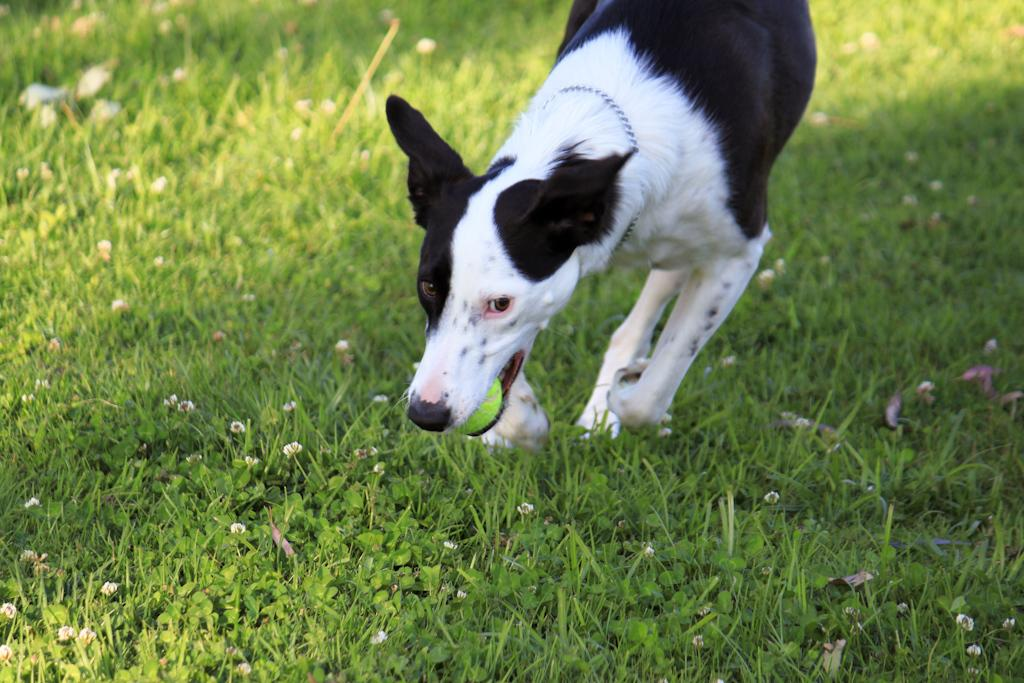What animal is present in the image? There is a dog in the image. What is the dog doing with its mouth? The dog is holding a ball in its mouth. What type of surface is visible at the bottom of the image? There is grass at the bottom of the image. What color crayon is the dog using to draw in the image? There is no crayon present in the image, and the dog is not drawing. 